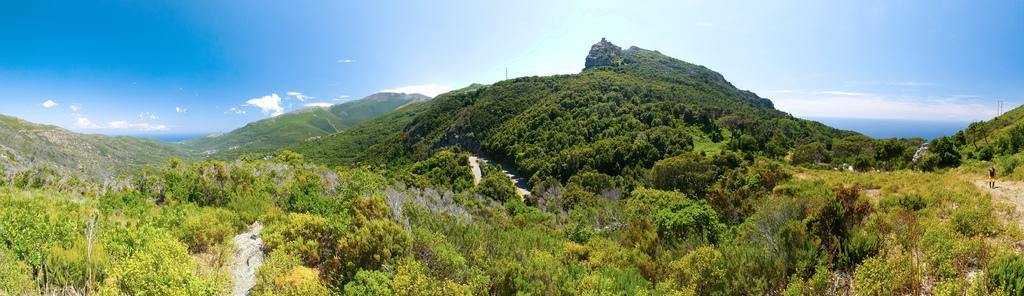What type of vegetation can be seen in the image? There are trees in the image. What geographical feature is visible in the background? There are mountains in the image. What type of ground cover is present in the image? There is grass in the image. What is visible in the top part of the image? The sky is visible in the image. What colors can be seen in the sky? The sky has a combination of white and blue colors. Can you hear the bell ringing in the image? There is no bell present in the image, so it cannot be heard. What type of food is being digested by the trees in the image? Trees do not have digestive systems, so they cannot digest food. 